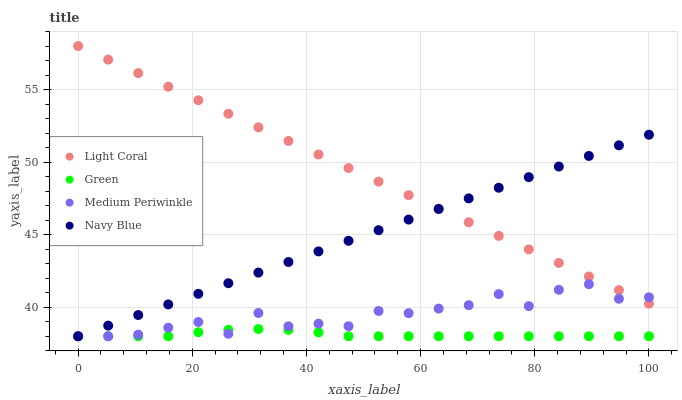Does Green have the minimum area under the curve?
Answer yes or no. Yes. Does Light Coral have the maximum area under the curve?
Answer yes or no. Yes. Does Medium Periwinkle have the minimum area under the curve?
Answer yes or no. No. Does Medium Periwinkle have the maximum area under the curve?
Answer yes or no. No. Is Navy Blue the smoothest?
Answer yes or no. Yes. Is Medium Periwinkle the roughest?
Answer yes or no. Yes. Is Green the smoothest?
Answer yes or no. No. Is Green the roughest?
Answer yes or no. No. Does Medium Periwinkle have the lowest value?
Answer yes or no. Yes. Does Light Coral have the highest value?
Answer yes or no. Yes. Does Medium Periwinkle have the highest value?
Answer yes or no. No. Is Green less than Light Coral?
Answer yes or no. Yes. Is Light Coral greater than Green?
Answer yes or no. Yes. Does Light Coral intersect Navy Blue?
Answer yes or no. Yes. Is Light Coral less than Navy Blue?
Answer yes or no. No. Is Light Coral greater than Navy Blue?
Answer yes or no. No. Does Green intersect Light Coral?
Answer yes or no. No. 